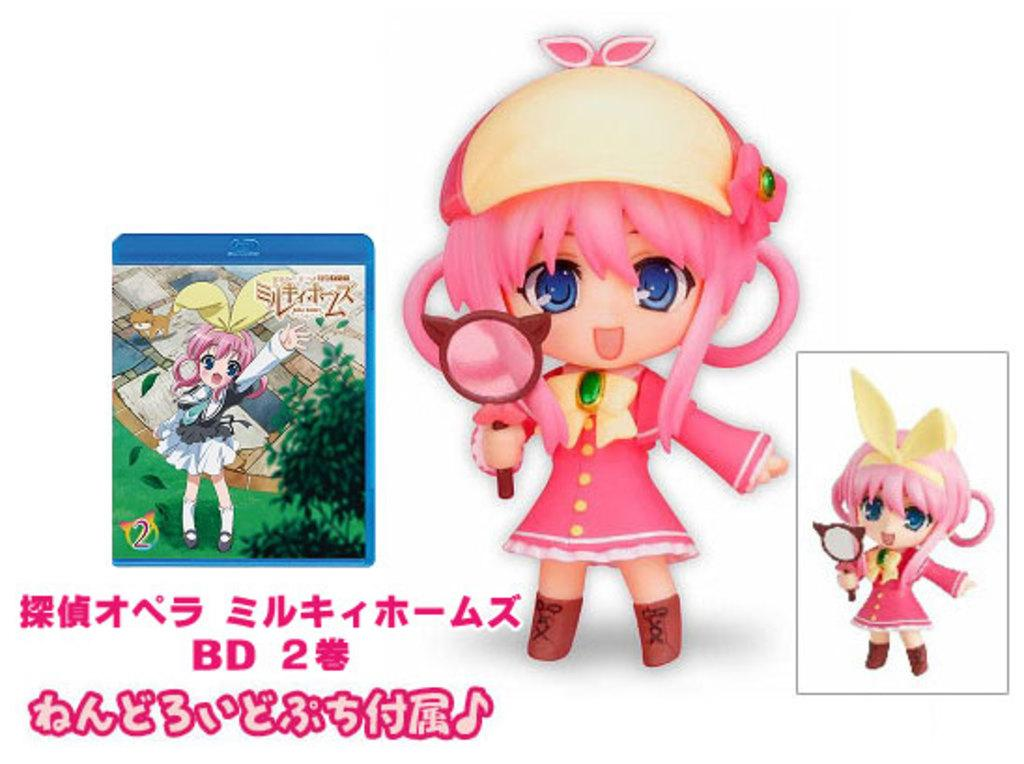What objects are present in the image? There are dolls in the image, and they are holding a mirror. What else can be seen in the image? There is a picture in the image, and there is text below the picture. How are the dolls dressed? The doll is wearing a pink dress and a cap. What type of lunch is the doll eating in the image? There is no lunch present in the image; the dolls are holding a mirror. How many spiders are crawling on the doll's cap in the image? There are no spiders present in the image; the doll is wearing a cap, but there are no spiders on it. 